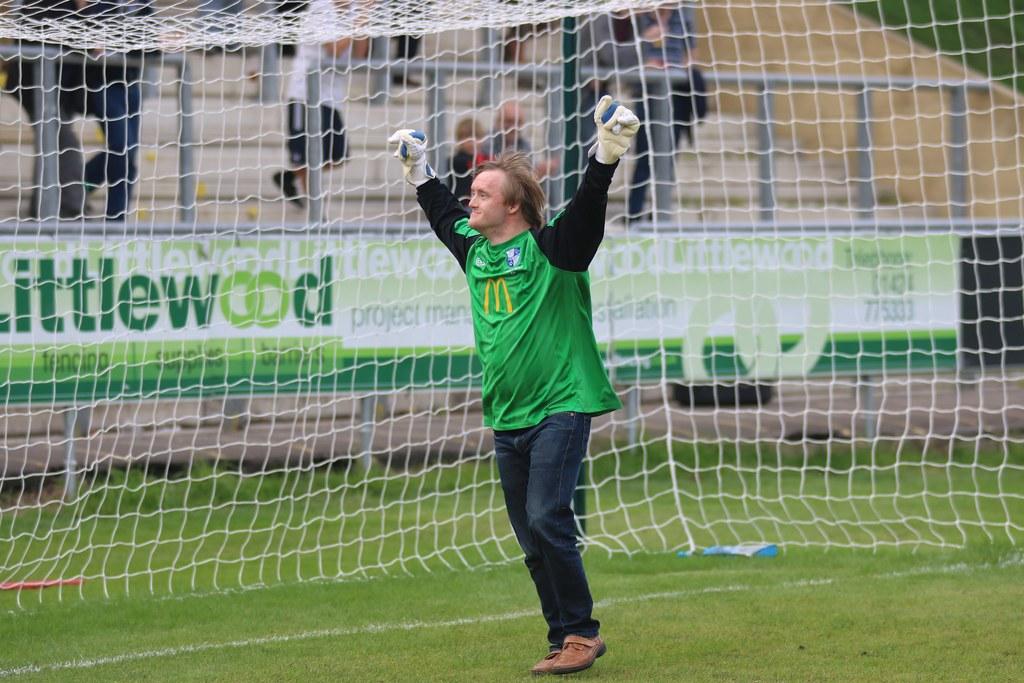What brand is on the man's jersey?
Your answer should be very brief. Mcdonald's. What is the name of the company being advertised on the banner?
Your answer should be very brief. Littlewood. 